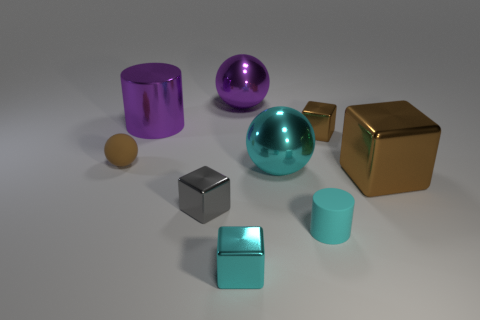There is a tiny cube that is the same color as the small cylinder; what is its material?
Make the answer very short. Metal. What number of spheres are the same color as the matte cylinder?
Ensure brevity in your answer.  1. There is a block that is the same color as the small matte cylinder; what size is it?
Provide a succinct answer. Small. What number of other things are the same shape as the tiny gray metallic object?
Give a very brief answer. 3. Is the number of big things less than the number of cyan metallic cubes?
Offer a very short reply. No. There is a object that is on the left side of the small cylinder and in front of the gray cube; what is its size?
Provide a succinct answer. Small. What size is the metal ball to the left of the metallic sphere right of the large metal ball behind the rubber sphere?
Keep it short and to the point. Large. What is the size of the cyan matte object?
Your answer should be very brief. Small. Is there anything else that has the same material as the small brown ball?
Give a very brief answer. Yes. Are there any large purple metal cylinders that are in front of the small rubber thing that is behind the large thing that is in front of the big cyan ball?
Ensure brevity in your answer.  No. 